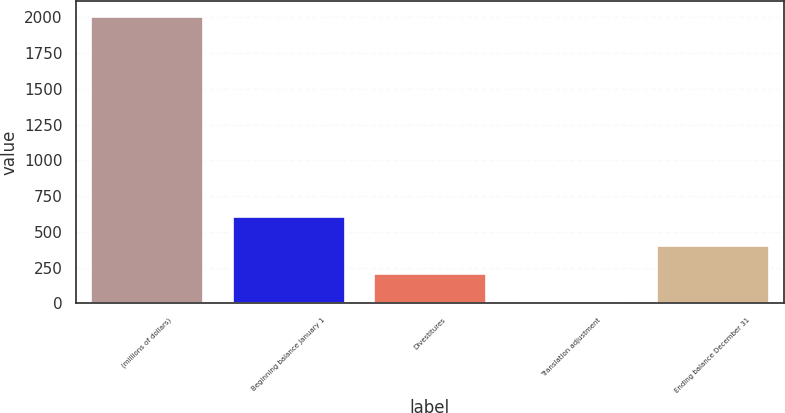Convert chart. <chart><loc_0><loc_0><loc_500><loc_500><bar_chart><fcel>(millions of dollars)<fcel>Beginning balance January 1<fcel>Divestitures<fcel>Translation adjustment<fcel>Ending balance December 31<nl><fcel>2012<fcel>610.18<fcel>209.66<fcel>9.4<fcel>409.92<nl></chart> 